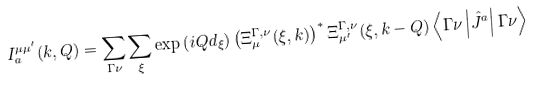Convert formula to latex. <formula><loc_0><loc_0><loc_500><loc_500>I _ { a } ^ { \mu \mu ^ { \prime } } ( { k } , { Q } ) = \sum _ { \Gamma \nu } \sum _ { \xi } \exp \left ( i { Q } { d } _ { \xi } \right ) \left ( \Xi _ { \mu } ^ { \Gamma , \nu } ( \xi , { k } ) \right ) ^ { * } \Xi _ { \mu ^ { \prime } } ^ { \Gamma , \nu } ( \xi , { k } - { Q } ) \left \langle \Gamma \nu \left | \hat { J } ^ { a } \right | \Gamma \nu \right \rangle</formula> 